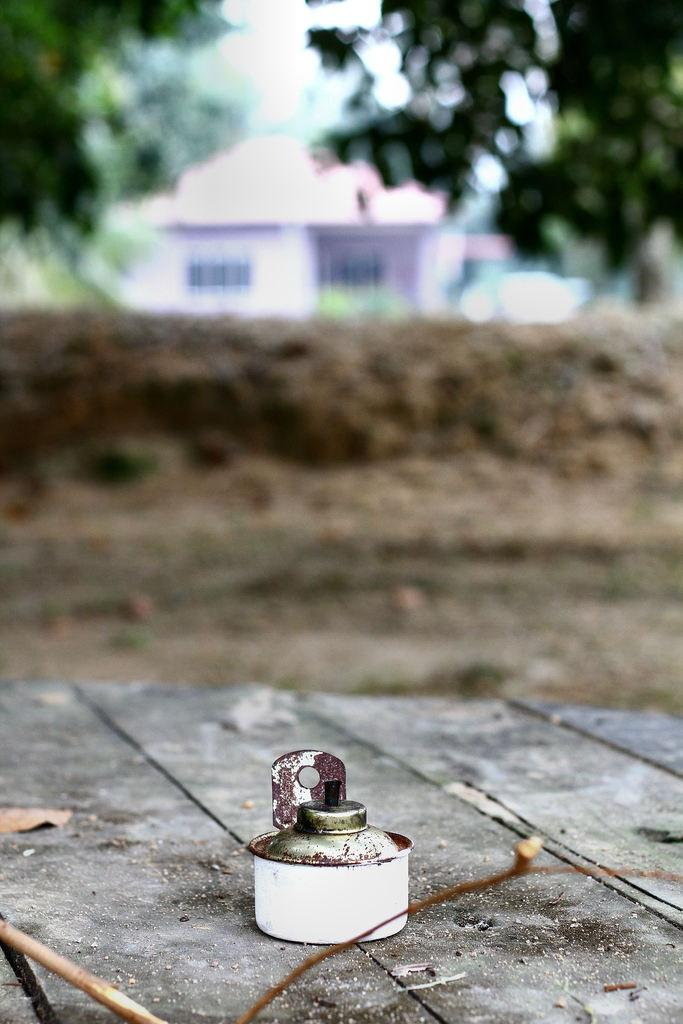What is the main object on the wooden surface in the image? There is an object on a wooden surface in the image, but the specific object is not mentioned in the facts. What type of natural material can be seen in the image? Dried leaves are present in the image. What can be seen beneath the wooden surface in the image? The ground is visible in the image. What type of structure is visible in the image? There is a house in the image. What type of vegetation is present in the image? Trees are present in the image. How would you describe the background of the image? The background of the image is blurred. Can you tell me how many horses are depicted in the image? There are no horses present in the image. What type of selection process is being shown in the image? There is no selection process depicted in the image. 